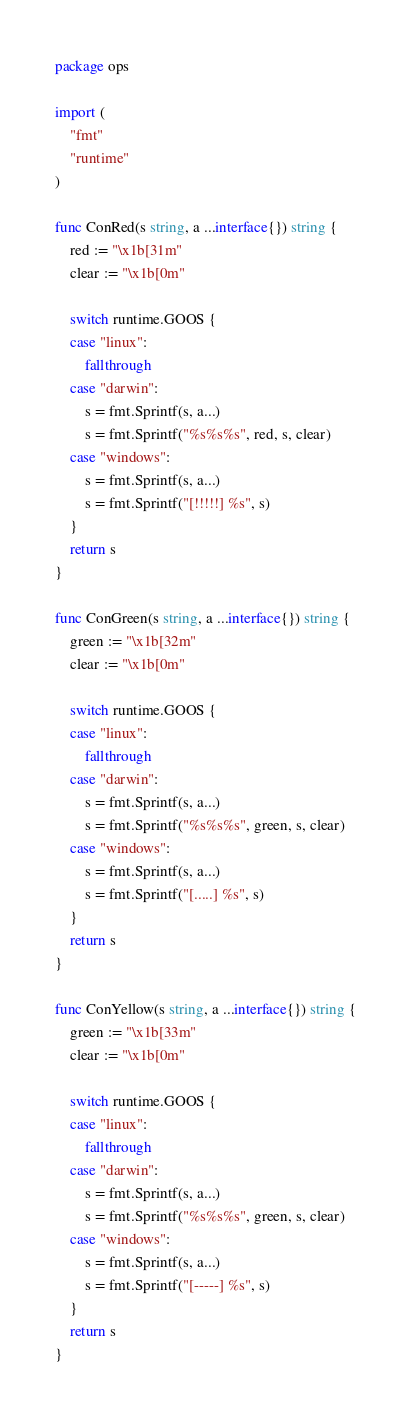<code> <loc_0><loc_0><loc_500><loc_500><_Go_>package ops

import (
	"fmt"
	"runtime"
)

func ConRed(s string, a ...interface{}) string {
	red := "\x1b[31m"
	clear := "\x1b[0m"

	switch runtime.GOOS {
	case "linux":
		fallthrough
	case "darwin":
		s = fmt.Sprintf(s, a...)
		s = fmt.Sprintf("%s%s%s", red, s, clear)
	case "windows":
		s = fmt.Sprintf(s, a...)
		s = fmt.Sprintf("[!!!!!] %s", s)
	}
	return s
}

func ConGreen(s string, a ...interface{}) string {
	green := "\x1b[32m"
	clear := "\x1b[0m"

	switch runtime.GOOS {
	case "linux":
		fallthrough
	case "darwin":
		s = fmt.Sprintf(s, a...)
		s = fmt.Sprintf("%s%s%s", green, s, clear)
	case "windows":
		s = fmt.Sprintf(s, a...)
		s = fmt.Sprintf("[.....] %s", s)
	}
	return s
}

func ConYellow(s string, a ...interface{}) string {
	green := "\x1b[33m"
	clear := "\x1b[0m"

	switch runtime.GOOS {
	case "linux":
		fallthrough
	case "darwin":
		s = fmt.Sprintf(s, a...)
		s = fmt.Sprintf("%s%s%s", green, s, clear)
	case "windows":
		s = fmt.Sprintf(s, a...)
		s = fmt.Sprintf("[-----] %s", s)
	}
	return s
}
</code> 